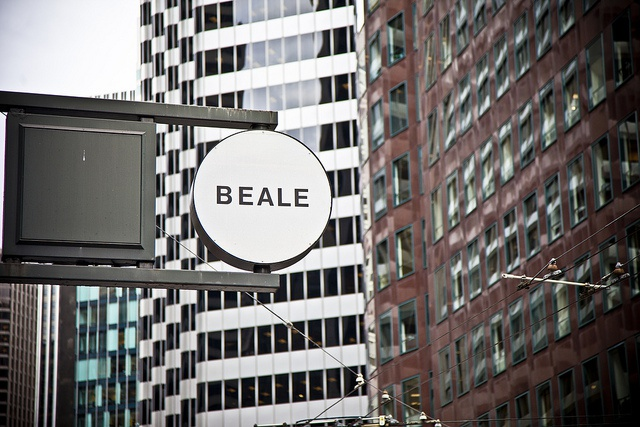Describe the objects in this image and their specific colors. I can see various objects in this image with different colors. 